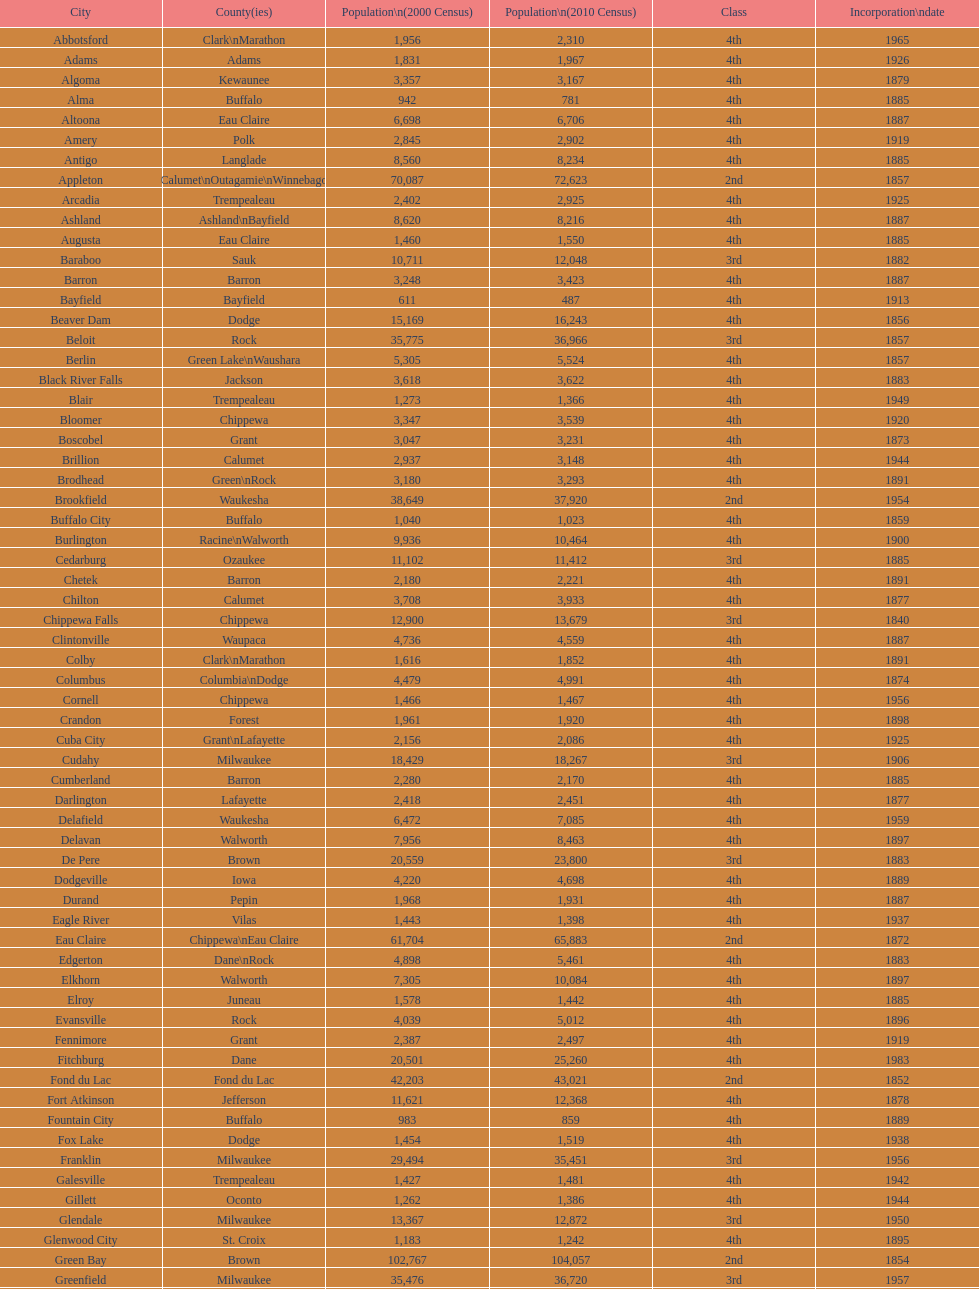In wisconsin, which city holds the distinction of being the first incorporated one? Chippewa Falls. 